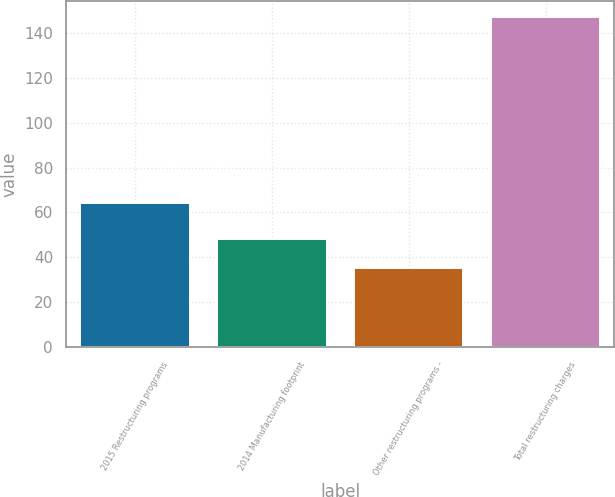Convert chart to OTSL. <chart><loc_0><loc_0><loc_500><loc_500><bar_chart><fcel>2015 Restructuring programs<fcel>2014 Manufacturing footprint<fcel>Other restructuring programs -<fcel>Total restructuring charges<nl><fcel>64<fcel>48<fcel>35<fcel>147<nl></chart> 